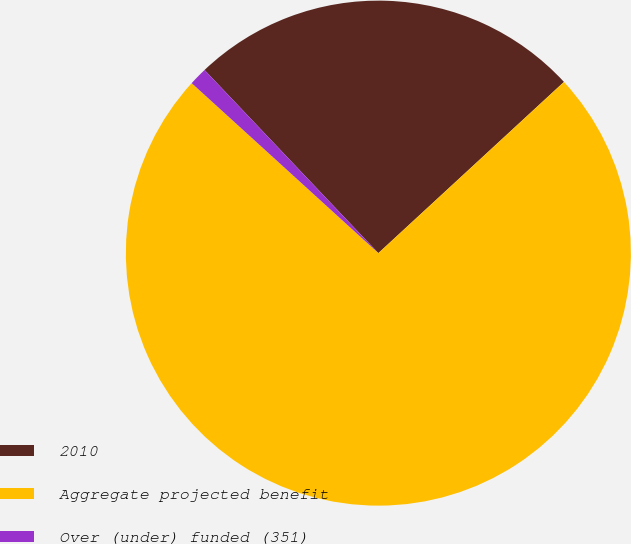Convert chart to OTSL. <chart><loc_0><loc_0><loc_500><loc_500><pie_chart><fcel>2010<fcel>Aggregate projected benefit<fcel>Over (under) funded (351)<nl><fcel>25.23%<fcel>73.62%<fcel>1.16%<nl></chart> 